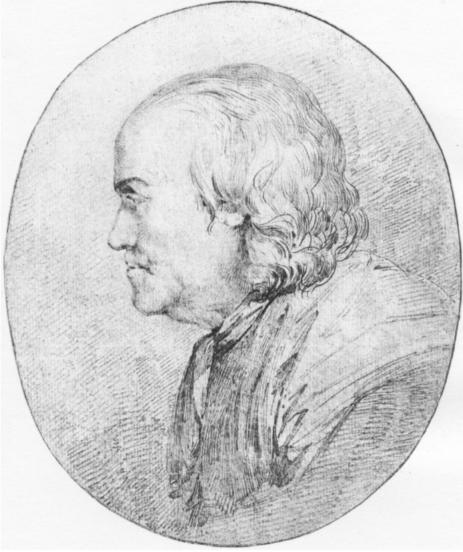Reflect on the emotional or psychological state conveyed by the subject in this portrait. What can be inferred about his demeanor? The man's profile and the overall composition of the portrait suggest a contemplative or solemn demeanor. His gaze is directed away, not engaging with the viewer, which might imply introspection or a reserved nature. The subtle details in his expression, such as the slight downturn of his lips and the relaxed brows, contribute to a feeling of calmness or perhaps melancholy. This could indicate a intellectual or philosophical personality, possibly reflective of the subject's role or status within his historical context. 